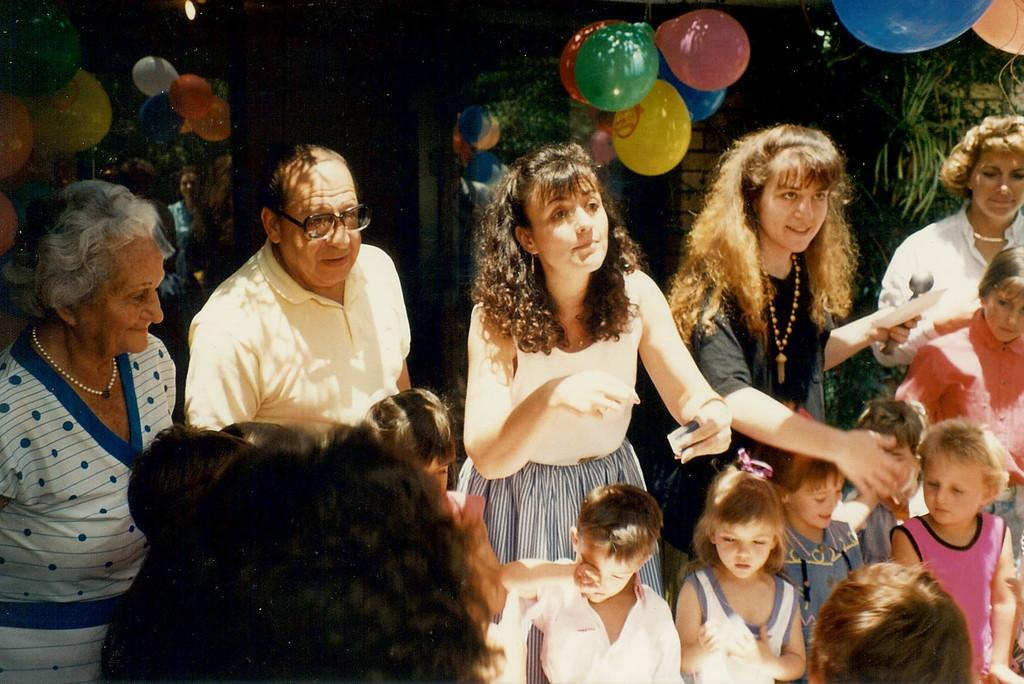Who is present at the event in the image? There are men, women, and children in the image. What type of event is taking place in the image? The event is a birthday party. What decorations can be seen in the image? There are balloons near the ceiling in the image. Can you tell me how many hydrants are visible in the image? There are no hydrants present in the image. What is the cause of the argument between the sun and the moon in the image? There is no argument between the sun and the moon in the image, as neither the sun nor the moon is present. 